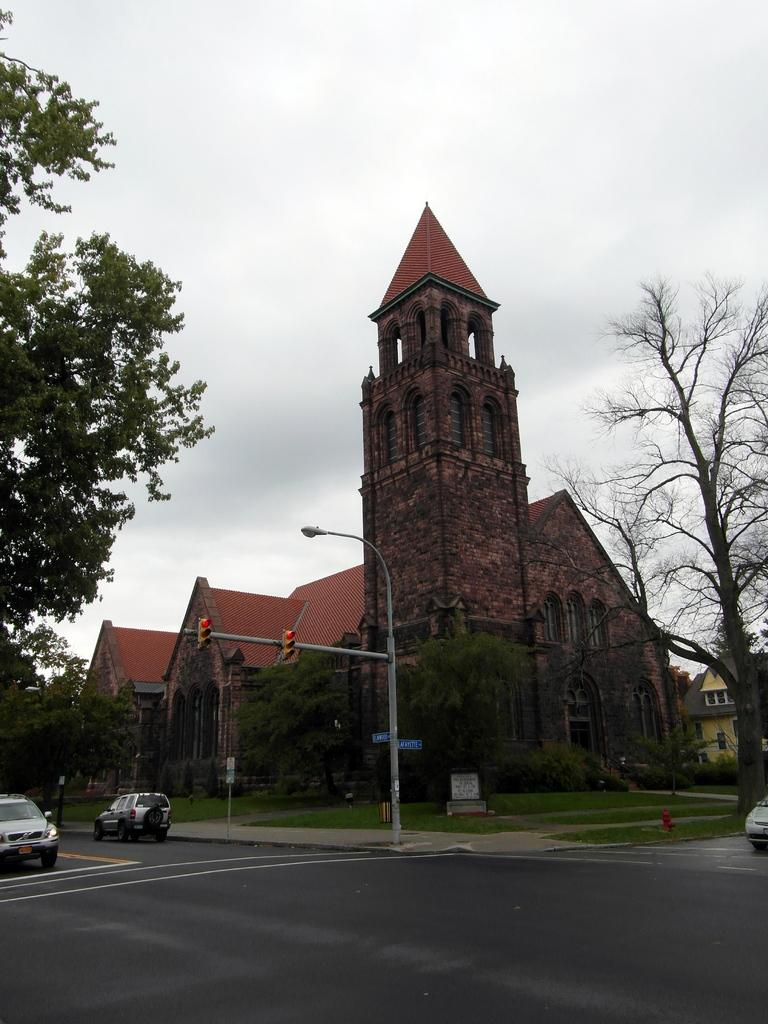What type of structures can be seen in the image? There are buildings in the image. What is happening on the road in the image? Vehicles are present on the road in the image. What is attached to the pole in the image? Traffic lights are visible on the pole. What type of vegetation is in the image? There are trees in the image. What is on the ground in the image? There is an object on the ground in the image. What can be seen in the background of the image? The sky is visible in the background of the image. Are there any pets visible in the image? There are no pets present in the image. Can you see a ship in the image? There is no ship present in the image. 